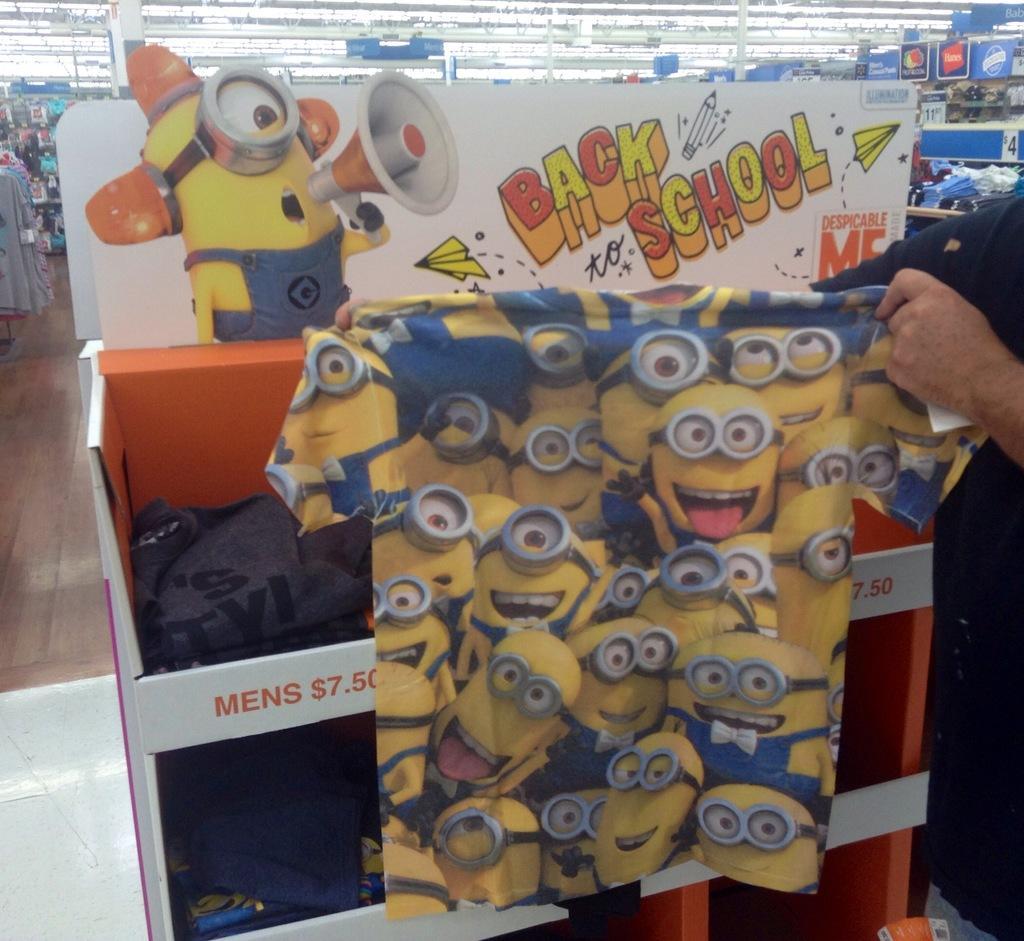Describe this image in one or two sentences. In this image, we can see a person holding a shirt and in the background, there are clothes and some boards. At the top, there is roof. 